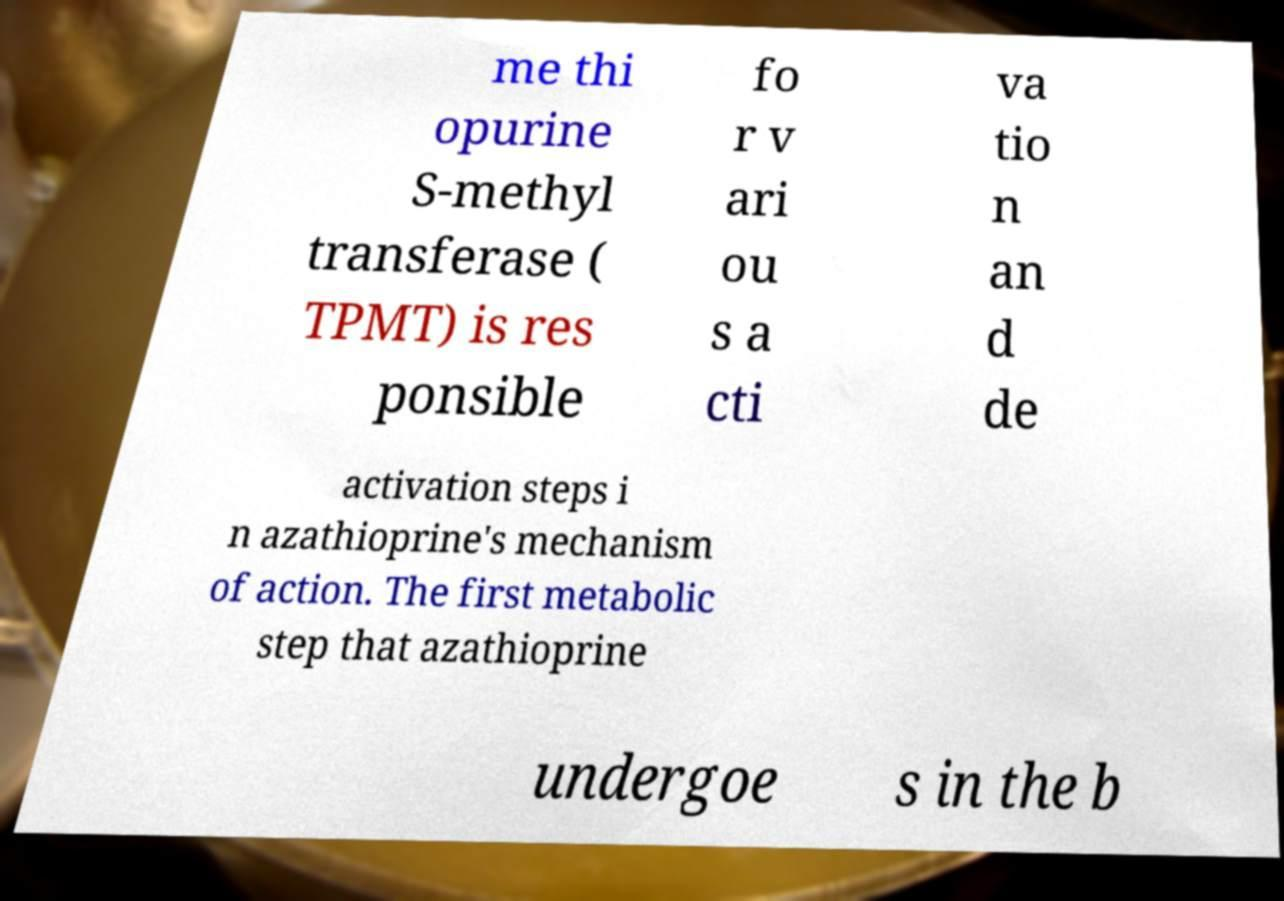Could you assist in decoding the text presented in this image and type it out clearly? me thi opurine S-methyl transferase ( TPMT) is res ponsible fo r v ari ou s a cti va tio n an d de activation steps i n azathioprine's mechanism of action. The first metabolic step that azathioprine undergoe s in the b 